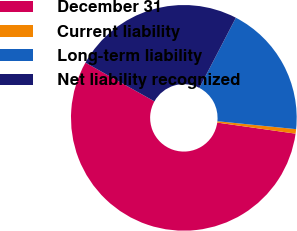<chart> <loc_0><loc_0><loc_500><loc_500><pie_chart><fcel>December 31<fcel>Current liability<fcel>Long-term liability<fcel>Net liability recognized<nl><fcel>55.9%<fcel>0.64%<fcel>18.97%<fcel>24.49%<nl></chart> 